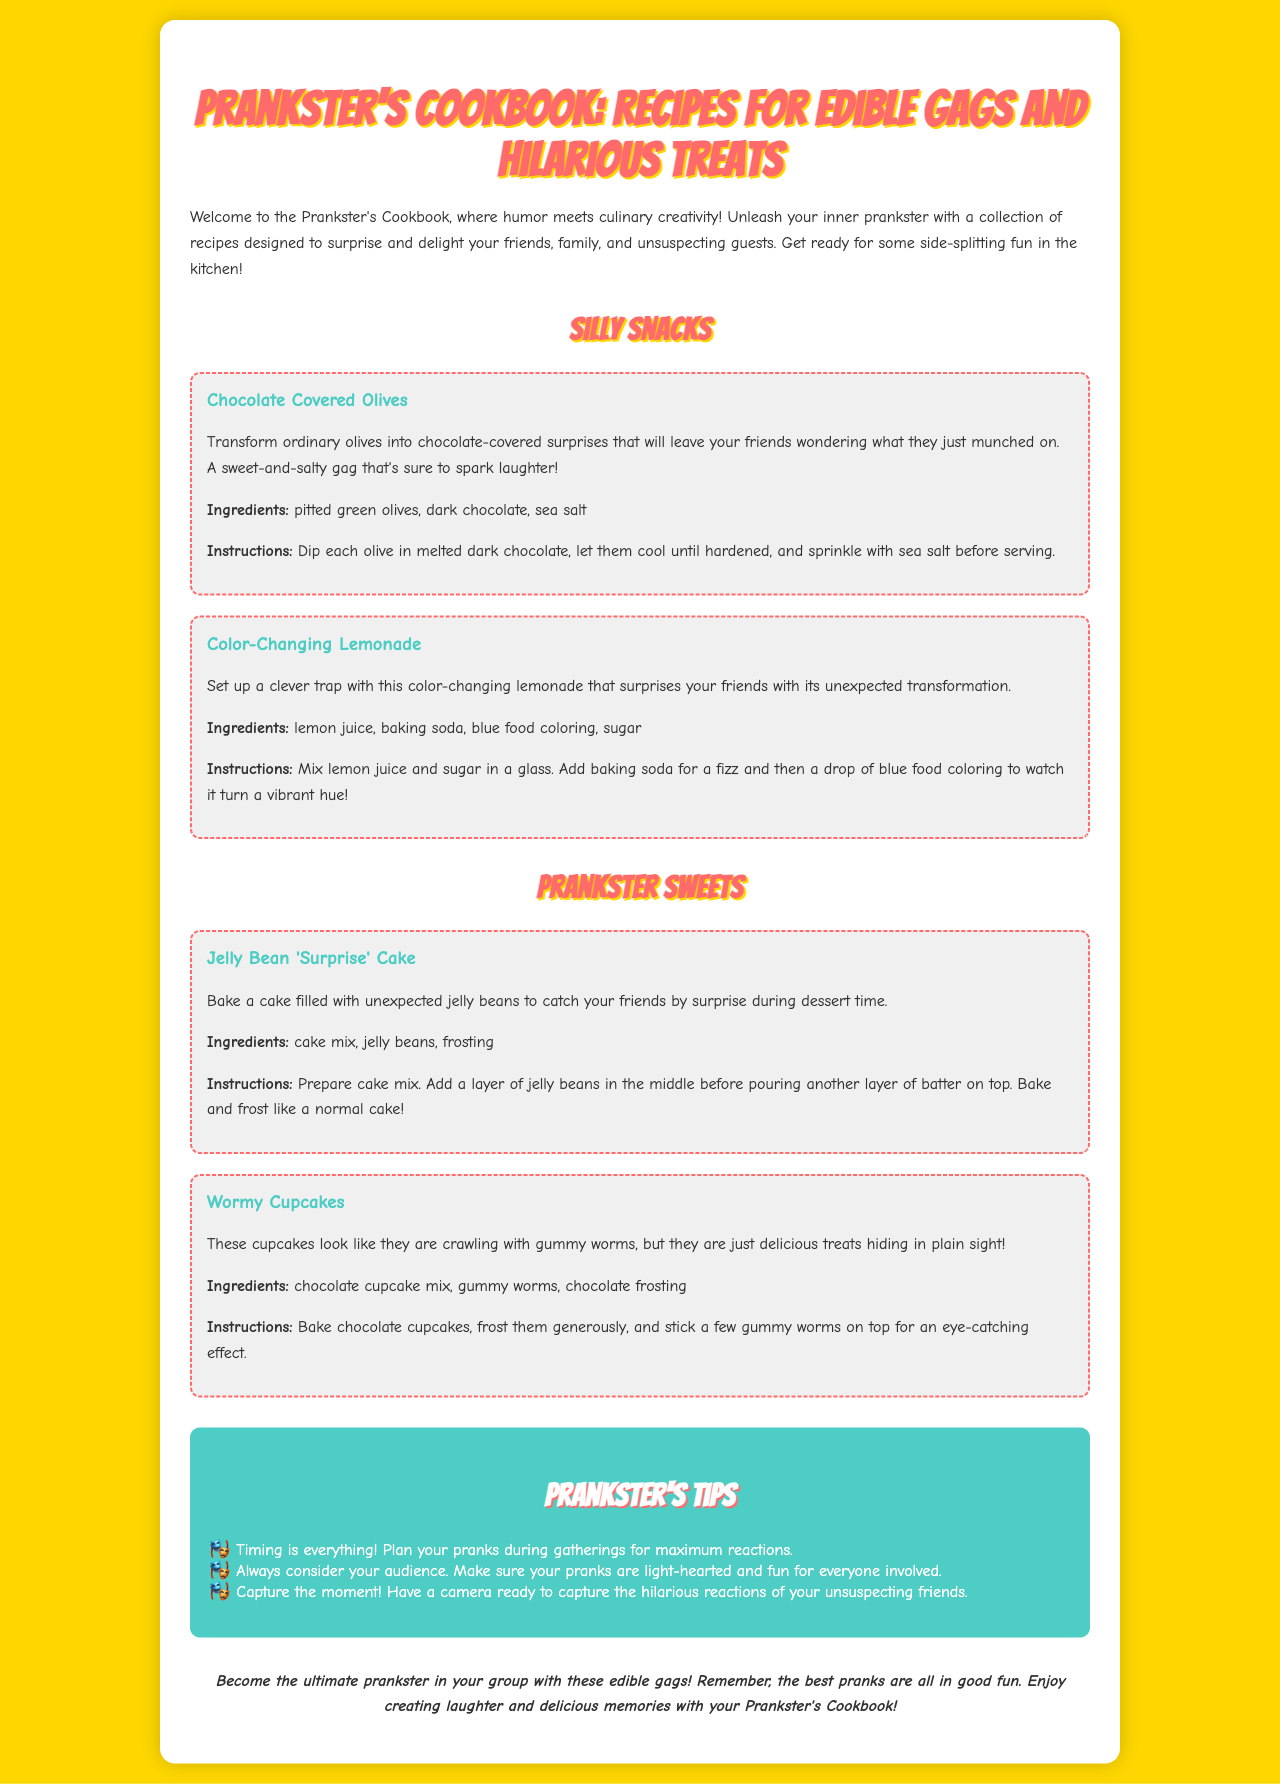What is the title of the document? The title of the document is prominently displayed at the top as "Prankster's Cookbook: Recipes for Edible Gags and Hilarious Treats."
Answer: Prankster's Cookbook: Recipes for Edible Gags and Hilarious Treats How many silly snacks are listed? Two silly snacks are featured: "Chocolate Covered Olives" and "Color-Changing Lemonade."
Answer: 2 What ingredient is used in both "Color-Changing Lemonade" and "Jelly Bean 'Surprise' Cake"? Lemon juice is an ingredient in "Color-Changing Lemonade" and is typically associated with baked goods like cakes.
Answer: Lemon juice What should you have ready to capture reactions? The document suggests having a camera ready to capture reactions during pranks.
Answer: Camera How are the "Wormy Cupcakes" decorated? The decoration involves placing gummy worms on top of the cupcakes for an eye-catching effect.
Answer: Gummy worms What is mentioned as essential for timing pranks? The text emphasizes planning pranks during gatherings to maximize reactions which indicates importance.
Answer: Timing What should the pranks be considered for the audience? The document advises ensuring that pranks are light-hearted and enjoyable for everyone involved.
Answer: Light-hearted How should the reactions of unsuspecting friends be captured? The document suggests to capture the moment, implying spontaneous reactions should be documented.
Answer: Captured 